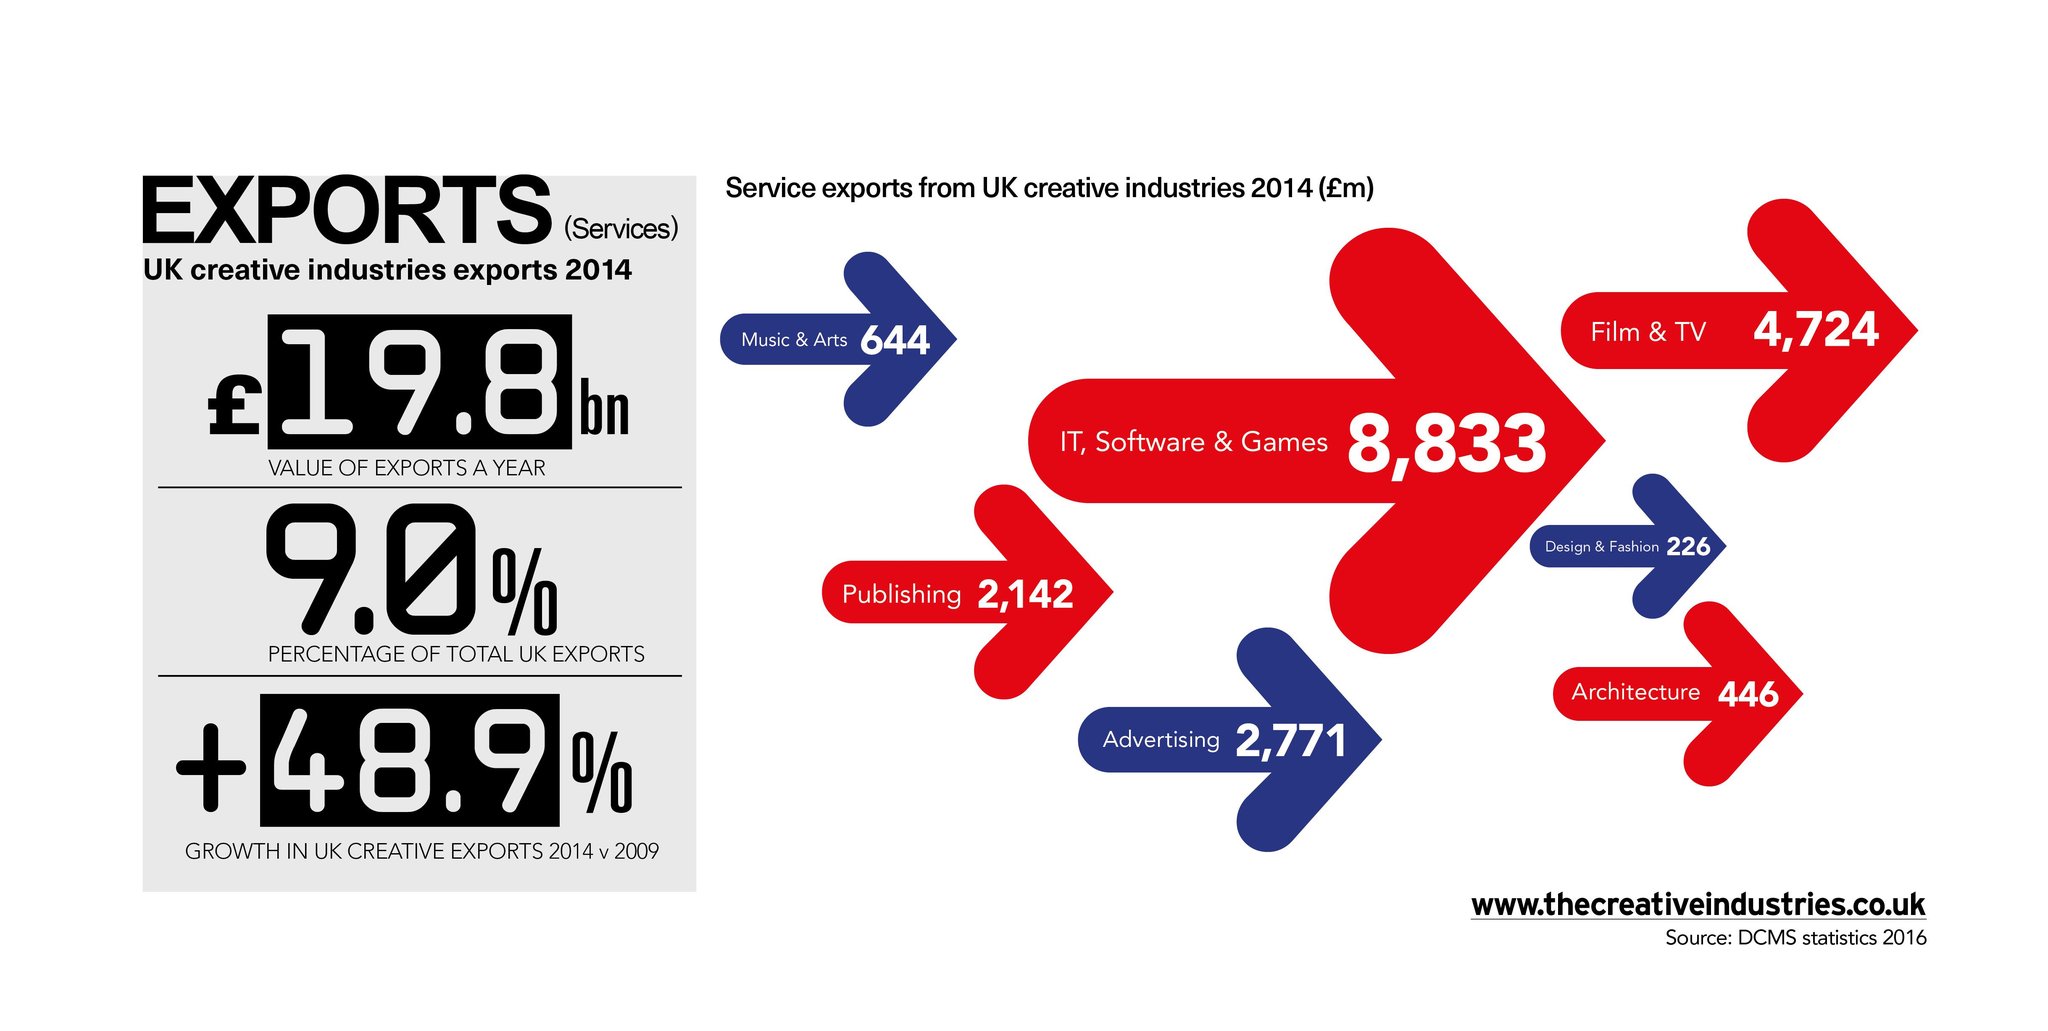Point out several critical features in this image. The creative industries in the UK have a significant impact on the country's economy, with various sectors contributing to the export of services. In particular, the IT, software, and gaming industries are among the areas with the highest service exports from the UK creative industries. The United Kingdom's creative industries export the least to the area of design and fashion. 